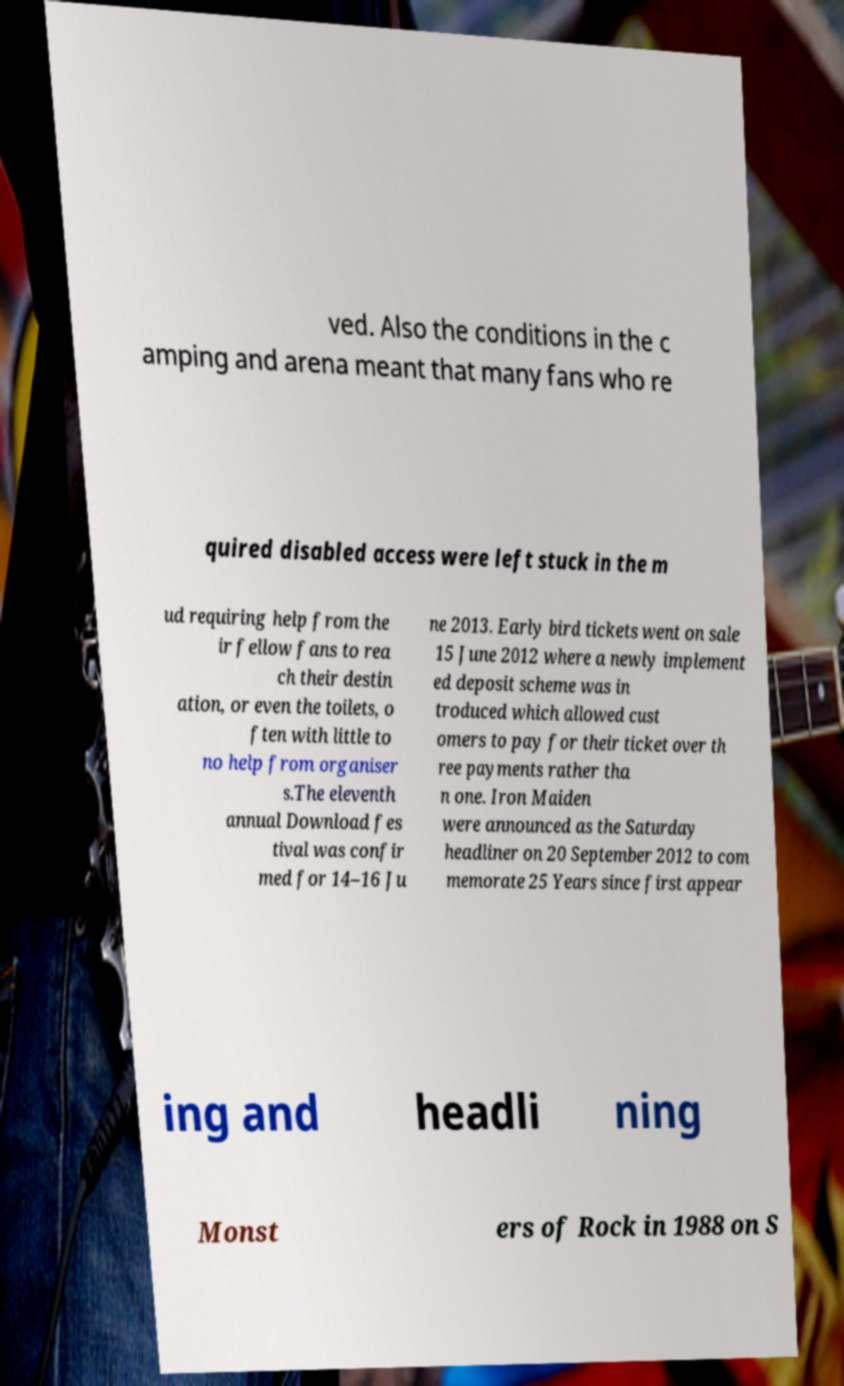For documentation purposes, I need the text within this image transcribed. Could you provide that? ved. Also the conditions in the c amping and arena meant that many fans who re quired disabled access were left stuck in the m ud requiring help from the ir fellow fans to rea ch their destin ation, or even the toilets, o ften with little to no help from organiser s.The eleventh annual Download fes tival was confir med for 14–16 Ju ne 2013. Early bird tickets went on sale 15 June 2012 where a newly implement ed deposit scheme was in troduced which allowed cust omers to pay for their ticket over th ree payments rather tha n one. Iron Maiden were announced as the Saturday headliner on 20 September 2012 to com memorate 25 Years since first appear ing and headli ning Monst ers of Rock in 1988 on S 